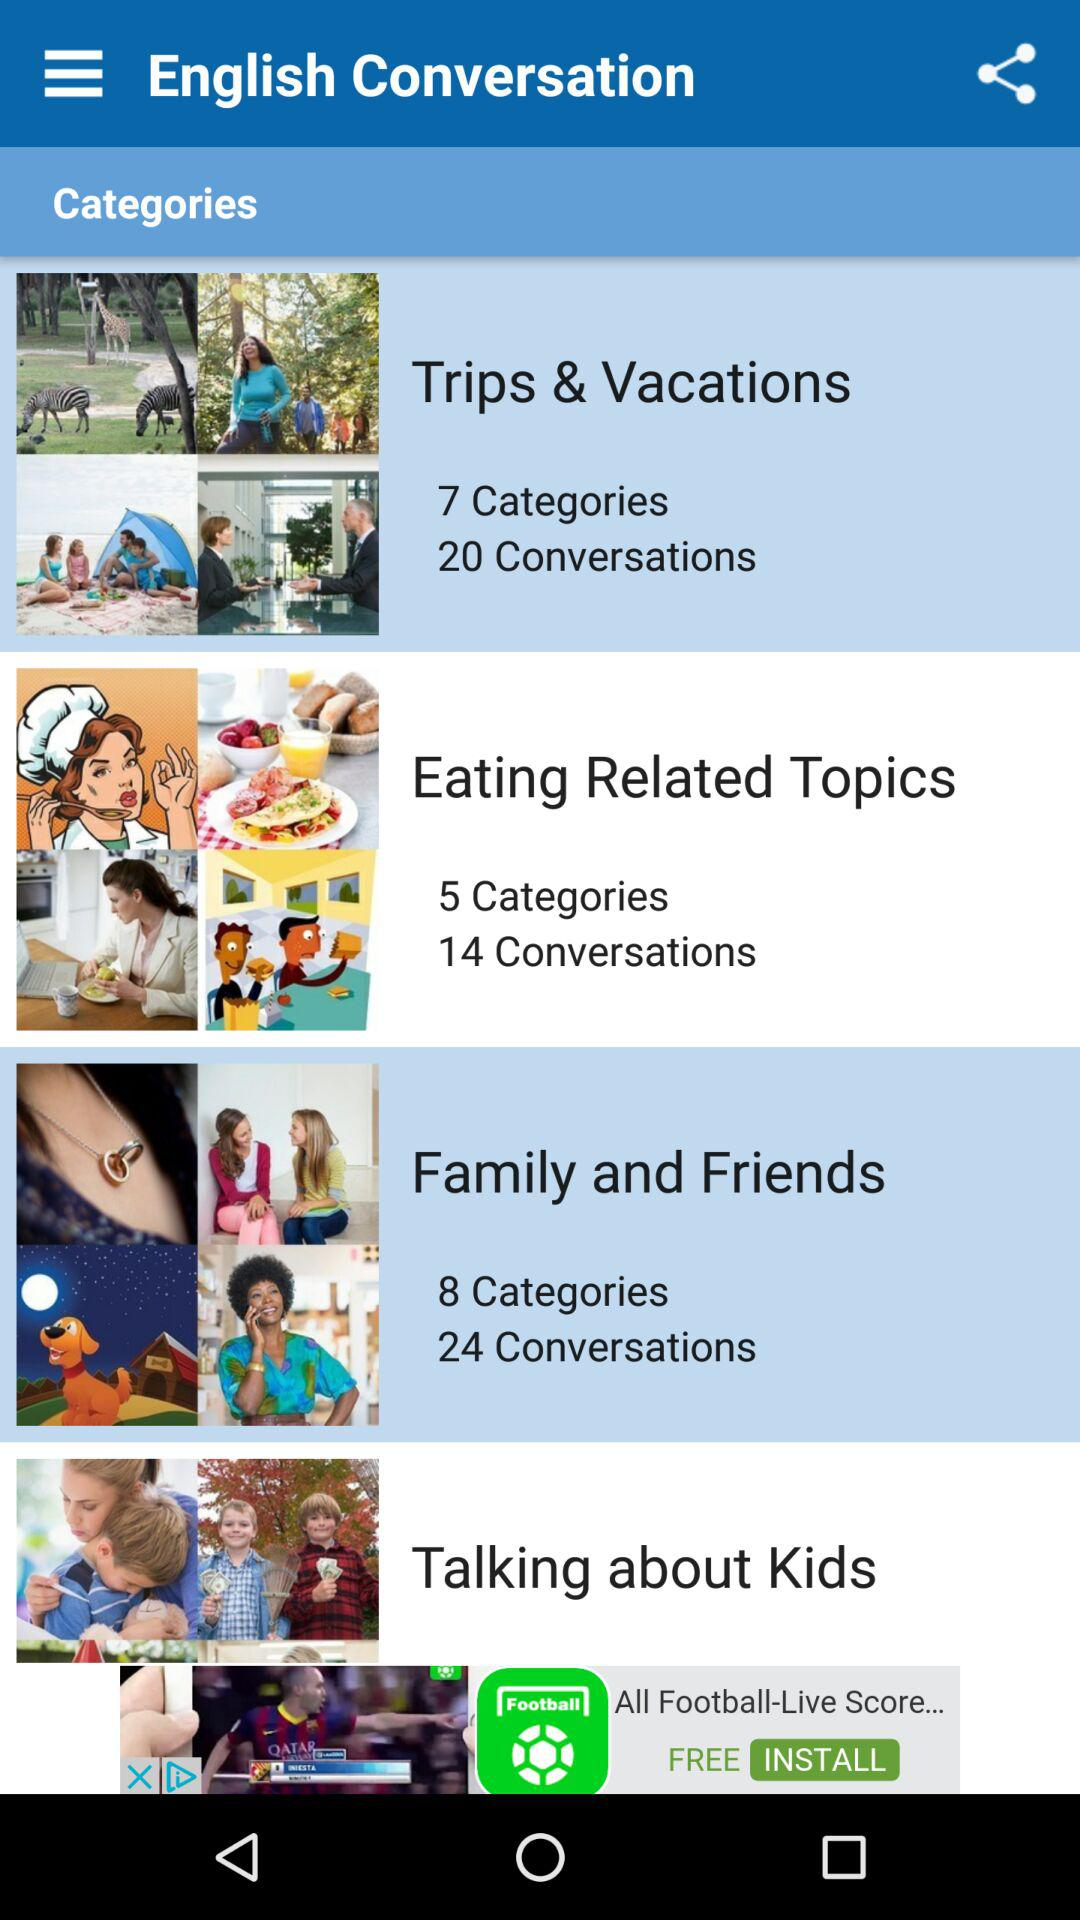How many categories are there in Trips and Vacations? There are 7 categories. 